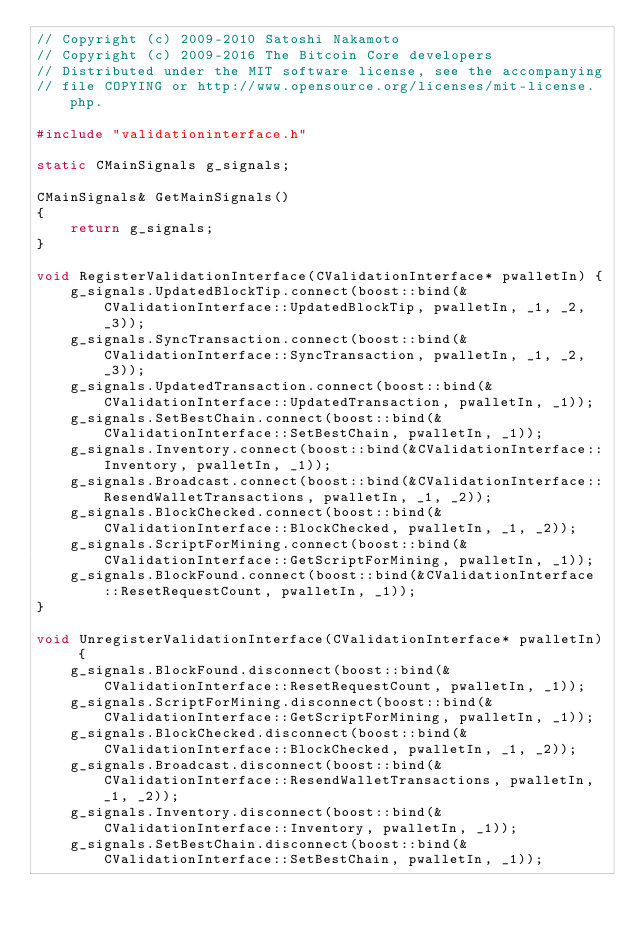Convert code to text. <code><loc_0><loc_0><loc_500><loc_500><_C++_>// Copyright (c) 2009-2010 Satoshi Nakamoto
// Copyright (c) 2009-2016 The Bitcoin Core developers
// Distributed under the MIT software license, see the accompanying
// file COPYING or http://www.opensource.org/licenses/mit-license.php.

#include "validationinterface.h"

static CMainSignals g_signals;

CMainSignals& GetMainSignals()
{
    return g_signals;
}

void RegisterValidationInterface(CValidationInterface* pwalletIn) {
    g_signals.UpdatedBlockTip.connect(boost::bind(&CValidationInterface::UpdatedBlockTip, pwalletIn, _1, _2, _3));
    g_signals.SyncTransaction.connect(boost::bind(&CValidationInterface::SyncTransaction, pwalletIn, _1, _2, _3));
    g_signals.UpdatedTransaction.connect(boost::bind(&CValidationInterface::UpdatedTransaction, pwalletIn, _1));
    g_signals.SetBestChain.connect(boost::bind(&CValidationInterface::SetBestChain, pwalletIn, _1));
    g_signals.Inventory.connect(boost::bind(&CValidationInterface::Inventory, pwalletIn, _1));
    g_signals.Broadcast.connect(boost::bind(&CValidationInterface::ResendWalletTransactions, pwalletIn, _1, _2));
    g_signals.BlockChecked.connect(boost::bind(&CValidationInterface::BlockChecked, pwalletIn, _1, _2));
    g_signals.ScriptForMining.connect(boost::bind(&CValidationInterface::GetScriptForMining, pwalletIn, _1));
    g_signals.BlockFound.connect(boost::bind(&CValidationInterface::ResetRequestCount, pwalletIn, _1));
}

void UnregisterValidationInterface(CValidationInterface* pwalletIn) {
    g_signals.BlockFound.disconnect(boost::bind(&CValidationInterface::ResetRequestCount, pwalletIn, _1));
    g_signals.ScriptForMining.disconnect(boost::bind(&CValidationInterface::GetScriptForMining, pwalletIn, _1));
    g_signals.BlockChecked.disconnect(boost::bind(&CValidationInterface::BlockChecked, pwalletIn, _1, _2));
    g_signals.Broadcast.disconnect(boost::bind(&CValidationInterface::ResendWalletTransactions, pwalletIn, _1, _2));
    g_signals.Inventory.disconnect(boost::bind(&CValidationInterface::Inventory, pwalletIn, _1));
    g_signals.SetBestChain.disconnect(boost::bind(&CValidationInterface::SetBestChain, pwalletIn, _1));</code> 